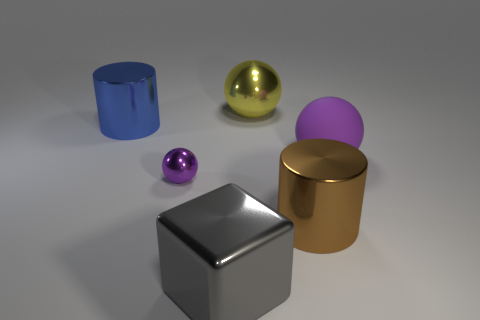Add 1 large matte objects. How many objects exist? 7 Subtract all blocks. How many objects are left? 5 Add 4 blue shiny things. How many blue shiny things exist? 5 Subtract 0 cyan balls. How many objects are left? 6 Subtract all big yellow spheres. Subtract all brown objects. How many objects are left? 4 Add 5 gray metallic objects. How many gray metallic objects are left? 6 